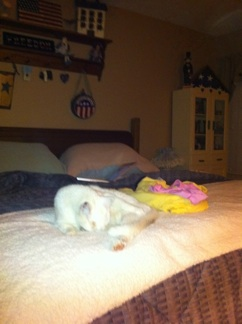Create a short story featuring the cat and this room. Once upon a time, in a cozy little bedroom filled with patriotic decor and warmth, a curious cat named Whiskers found solace on a plush, brown blanket. Beside Whiskers lay a vibrant, yellow-and-pink toy - its favorite plaything. Whiskers would spend hours exploring the nooks and crannies of the room, only to return to its favorite spot on the bed, where it would curl up and dream of exciting adventures. 